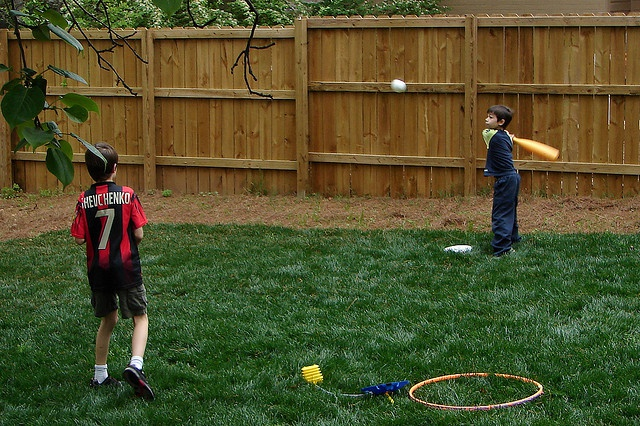Describe the objects in this image and their specific colors. I can see people in darkgreen, black, maroon, brown, and gray tones, people in darkgreen, black, navy, gray, and darkblue tones, baseball bat in darkgreen, khaki, brown, and orange tones, sports ball in darkgreen, white, darkgray, gray, and olive tones, and frisbee in darkgreen, white, black, darkgray, and gray tones in this image. 